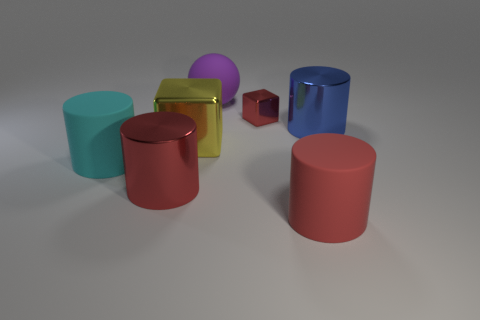There is a large matte cylinder to the right of the tiny thing that is to the right of the matte sphere; what is its color? The large matte cylinder situated to the right of the diminutive object, which in turn lies to the right of the matte sphere, exhibits a rich burgundy hue. 